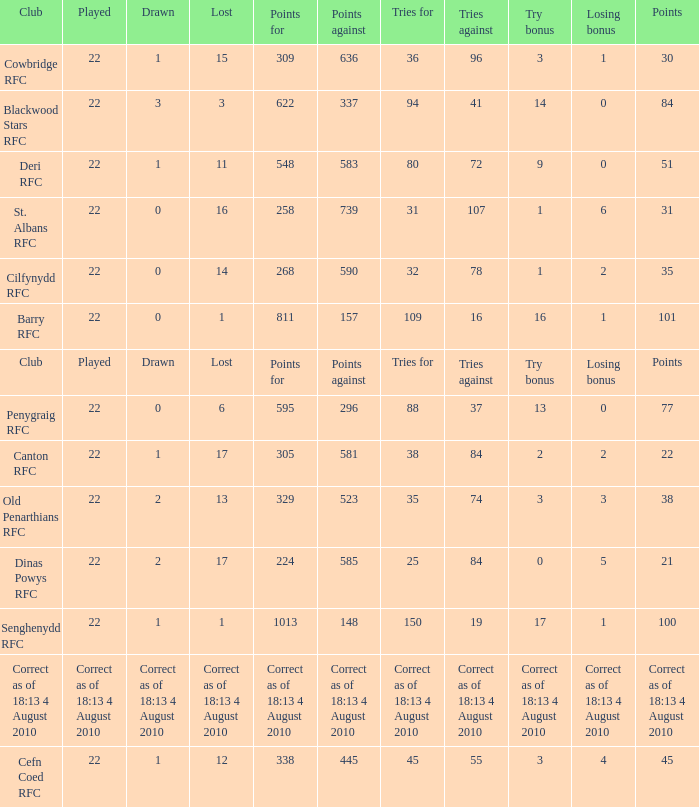What is the lost when the club was Barry RFC? 1.0. 